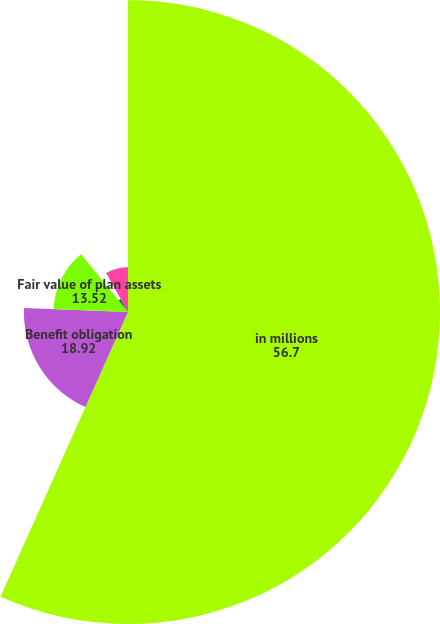Convert chart. <chart><loc_0><loc_0><loc_500><loc_500><pie_chart><fcel>in millions<fcel>Benefit obligation<fcel>Fair value of plan assets<fcel>Funded status<fcel>Accrued compensation and<nl><fcel>56.7%<fcel>18.92%<fcel>13.52%<fcel>2.73%<fcel>8.13%<nl></chart> 